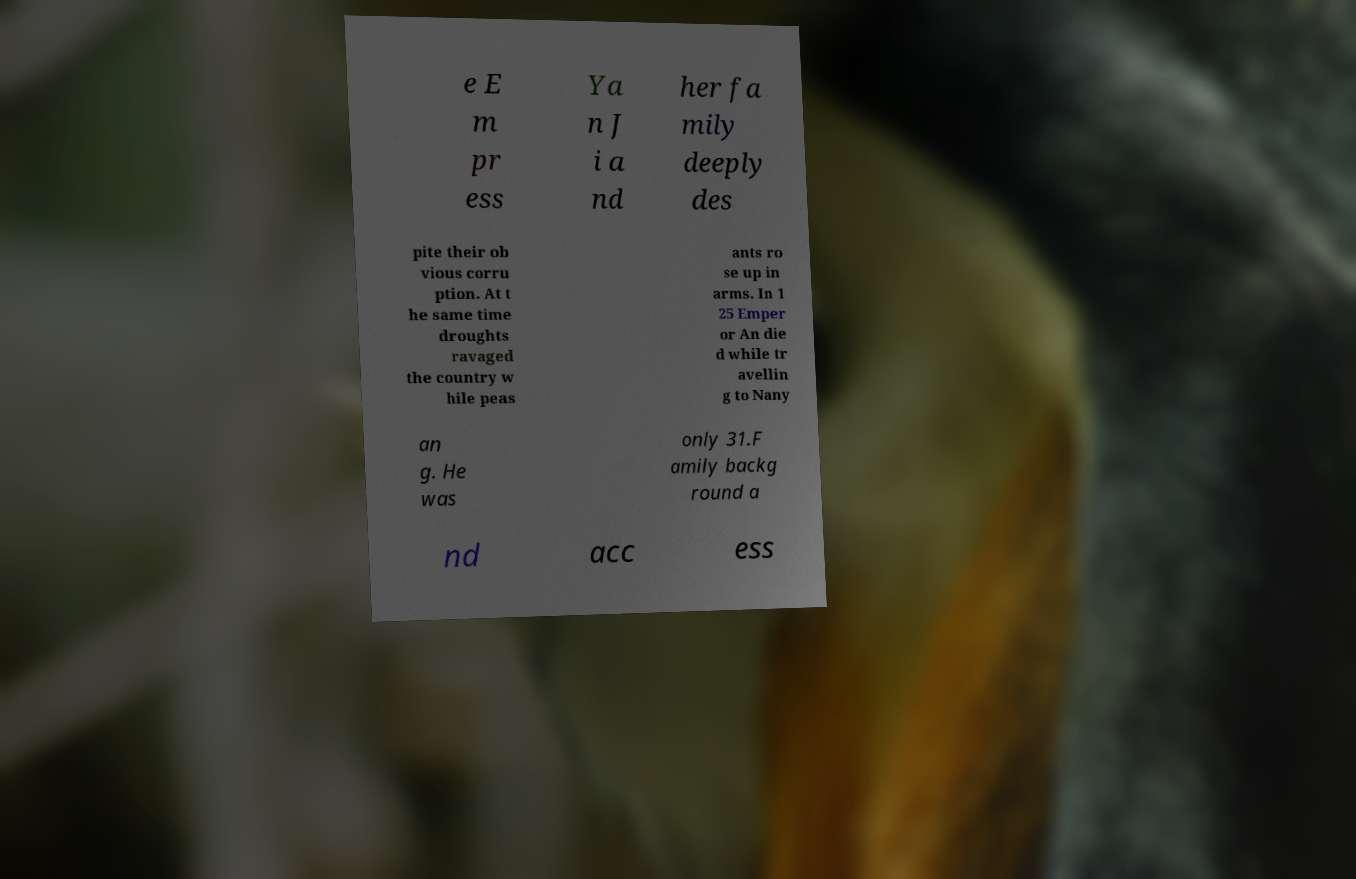Can you read and provide the text displayed in the image?This photo seems to have some interesting text. Can you extract and type it out for me? e E m pr ess Ya n J i a nd her fa mily deeply des pite their ob vious corru ption. At t he same time droughts ravaged the country w hile peas ants ro se up in arms. In 1 25 Emper or An die d while tr avellin g to Nany an g. He was only 31.F amily backg round a nd acc ess 